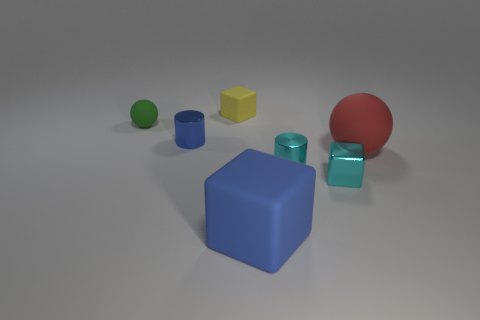Subtract all yellow rubber blocks. How many blocks are left? 2 Add 1 green spheres. How many objects exist? 8 Subtract all blue cubes. How many cubes are left? 2 Subtract 1 balls. How many balls are left? 1 Subtract 0 gray spheres. How many objects are left? 7 Subtract all spheres. How many objects are left? 5 Subtract all yellow blocks. Subtract all red balls. How many blocks are left? 2 Subtract all gray blocks. How many green balls are left? 1 Subtract all small gray matte objects. Subtract all yellow things. How many objects are left? 6 Add 5 green things. How many green things are left? 6 